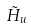<formula> <loc_0><loc_0><loc_500><loc_500>\tilde { H } _ { u }</formula> 